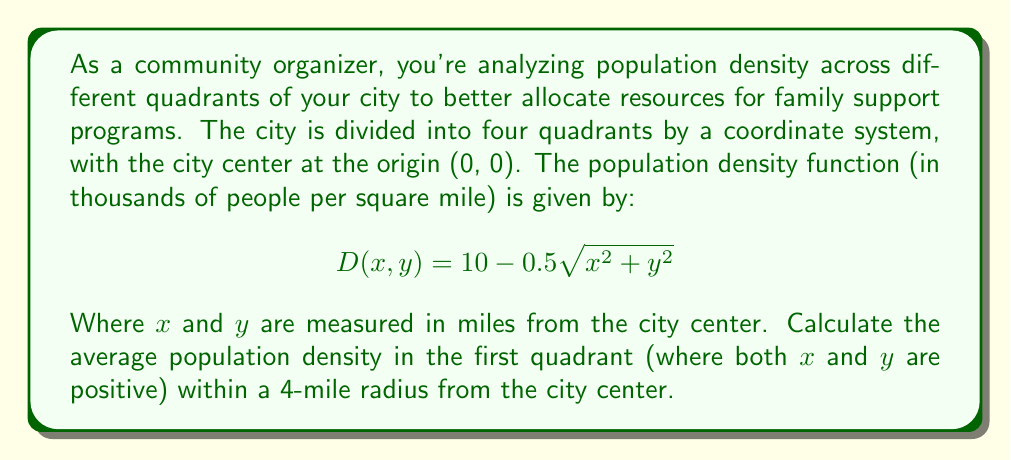Give your solution to this math problem. To solve this problem, we need to follow these steps:

1) The average population density is given by the volume under the density function divided by the area of the region.

2) We need to set up a double integral to calculate the volume under the density function in the first quadrant within a 4-mile radius:

   $$\int_{0}^{4} \int_{0}^{\sqrt{16-y^2}} (10 - 0.5\sqrt{x^2 + y^2}) dx dy$$

3) To simplify the calculation, we can switch to polar coordinates:
   $x = r\cos\theta$, $y = r\sin\theta$
   The Jacobian for this transformation is $r$.

4) In polar coordinates, the integral becomes:

   $$\int_{0}^{\pi/2} \int_{0}^{4} (10 - 0.5r) \cdot r \, dr d\theta$$

5) Let's solve the inner integral first:

   $$\int_{0}^{4} (10r - 0.5r^2) dr = [5r^2 - \frac{1}{6}r^3]_{0}^{4} = 80 - \frac{128}{3} = \frac{112}{3}$$

6) Now the outer integral:

   $$\int_{0}^{\pi/2} \frac{112}{3} d\theta = \frac{112}{3} \cdot \frac{\pi}{2} = \frac{56\pi}{3}$$

7) The area of the region (a quarter circle with radius 4) is:

   $$A = \frac{1}{4} \pi r^2 = 4\pi$$

8) The average density is the volume divided by the area:

   $$\text{Average Density} = \frac{56\pi/3}{4\pi} = \frac{14}{3} \approx 4.67$$
Answer: The average population density in the first quadrant within a 4-mile radius from the city center is $\frac{14}{3}$ thousand people per square mile, or approximately 4,667 people per square mile. 